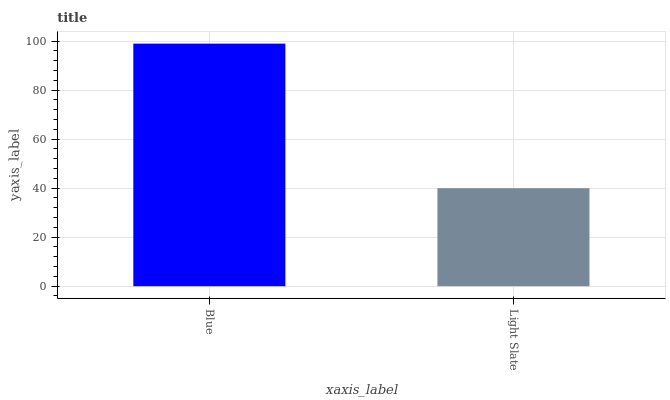Is Light Slate the maximum?
Answer yes or no. No. Is Blue greater than Light Slate?
Answer yes or no. Yes. Is Light Slate less than Blue?
Answer yes or no. Yes. Is Light Slate greater than Blue?
Answer yes or no. No. Is Blue less than Light Slate?
Answer yes or no. No. Is Blue the high median?
Answer yes or no. Yes. Is Light Slate the low median?
Answer yes or no. Yes. Is Light Slate the high median?
Answer yes or no. No. Is Blue the low median?
Answer yes or no. No. 